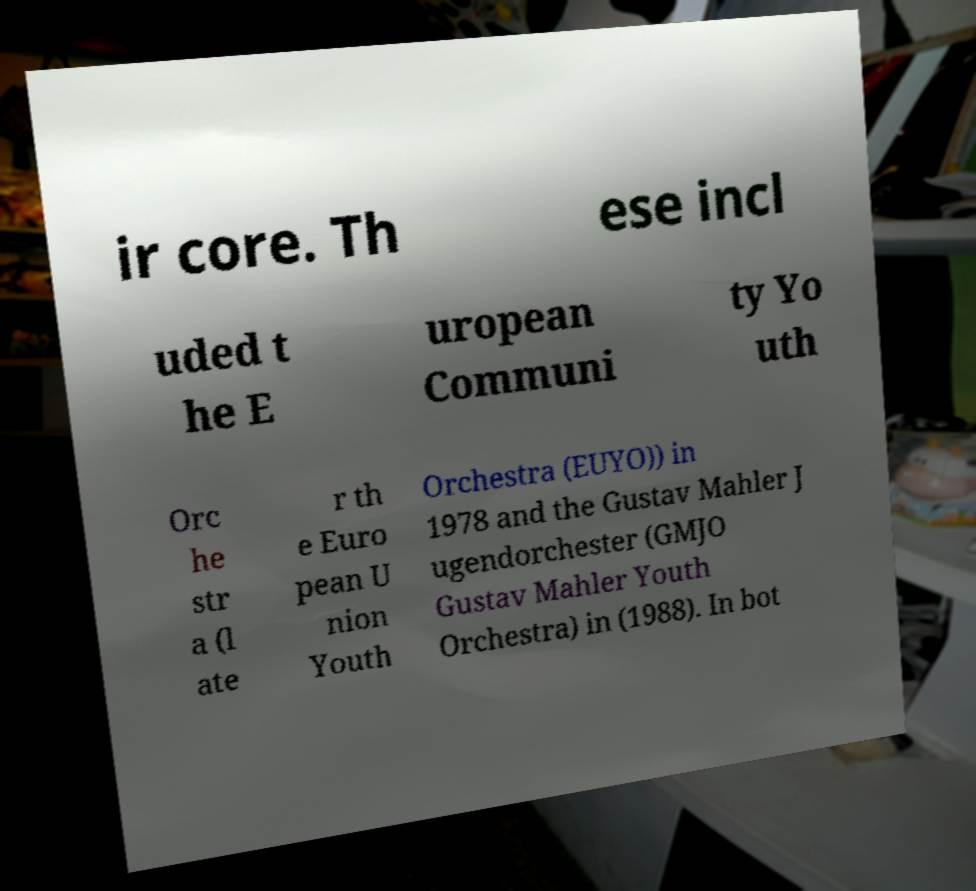Can you read and provide the text displayed in the image?This photo seems to have some interesting text. Can you extract and type it out for me? ir core. Th ese incl uded t he E uropean Communi ty Yo uth Orc he str a (l ate r th e Euro pean U nion Youth Orchestra (EUYO)) in 1978 and the Gustav Mahler J ugendorchester (GMJO Gustav Mahler Youth Orchestra) in (1988). In bot 